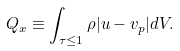<formula> <loc_0><loc_0><loc_500><loc_500>Q _ { x } \equiv \int _ { \tau \leq 1 } \rho | u - v _ { p } | d V .</formula> 